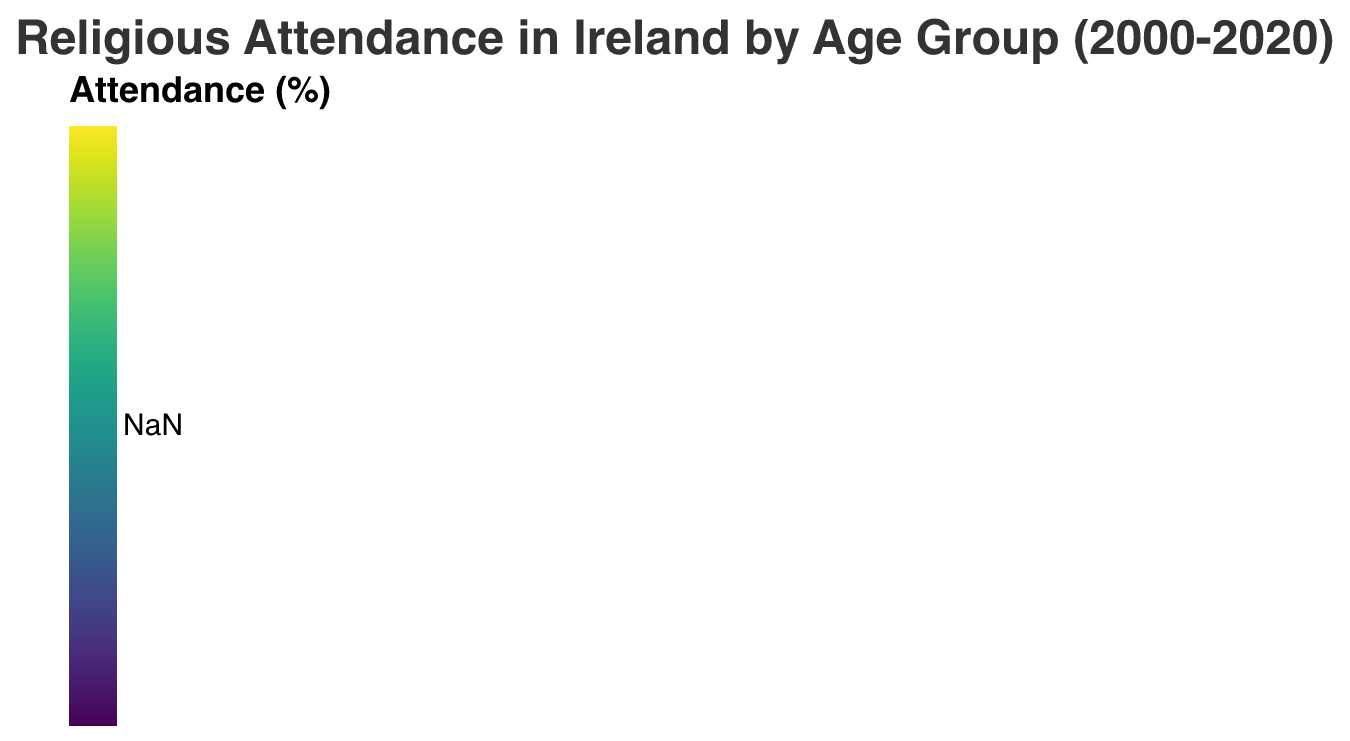What's the overall trend in daily attendance at religious services from 2000 to 2020 across all age groups? In the figure, daily attendance for each age group is shown across the years. Observe the color intensity representing daily attendance from 2000 to 2020. For all age groups, the intensity decreases, indicating a downward trend.
Answer: Downward trend Which age group shows the highest weekly attendance at religious services in 2015? Look at the 2015 column and compare the color intensities for weekly attendance across all age groups. The "50-69" age group has the highest color intensity for weekly attendance in that year.
Answer: 50-69 In which year did the 18-29 age group see the most significant decline in daily attendance? Compare the color intensities for daily attendance of the 18-29 age group over different years. The transition from 2005 to 2010 shows the most significant decline.
Answer: 2010 How does the frequency of occasional attendance change in the 30-49 age group from 2000 to 2020? Observe the color intensities for occasional attendance in the 30-49 age group from 2000 to 2020. The intensity increases, indicating an increase in occasional attendance over the years.
Answer: Increase Which attendance type shows the most stable trend across all age groups from 2000 to 2020? Compare the stability of color intensities of all attendance types across years. No attendance remains relatively stable across all age groups and years.
Answer: No attendance For the 50-69 age group in 2020, which attendance type had the highest frequency? In the 2020 column for the 50-69 age group, compare the color intensity of all attendance types. Weekly attendance has the highest color intensity.
Answer: Weekly attendance What is the trend in monthly attendance at religious services for the 70+ age group from 2000 to 2020? Observe the color intensities representing monthly attendance for the 70+ age group over the years. The intensity increases, suggesting an upward trend in monthly attendance.
Answer: Upward trend Compare the daily attendance at religious services between the 18-29 and 70+ age groups in 2000. Which one is higher? Look at the color intensities for daily attendance in 2000 for the 18-29 and 70+ age groups. The 70+ age group has a higher intensity.
Answer: 70+ How did weekly attendance at religious services change from 2000 to 2020 for the 30-49 age group? Observe the color intensities for weekly attendance in the 30-49 age group from 2000 to 2020. The intensity decreases over time, indicating a reduction in weekly attendance.
Answer: Decrease What was the most frequent type of attendance for the 18-29 age group in 2020? In the 2020 column for the 18-29 age group, compare the color intensities of all attendance types. Monthly attendance has the highest color intensity.
Answer: Monthly attendance 